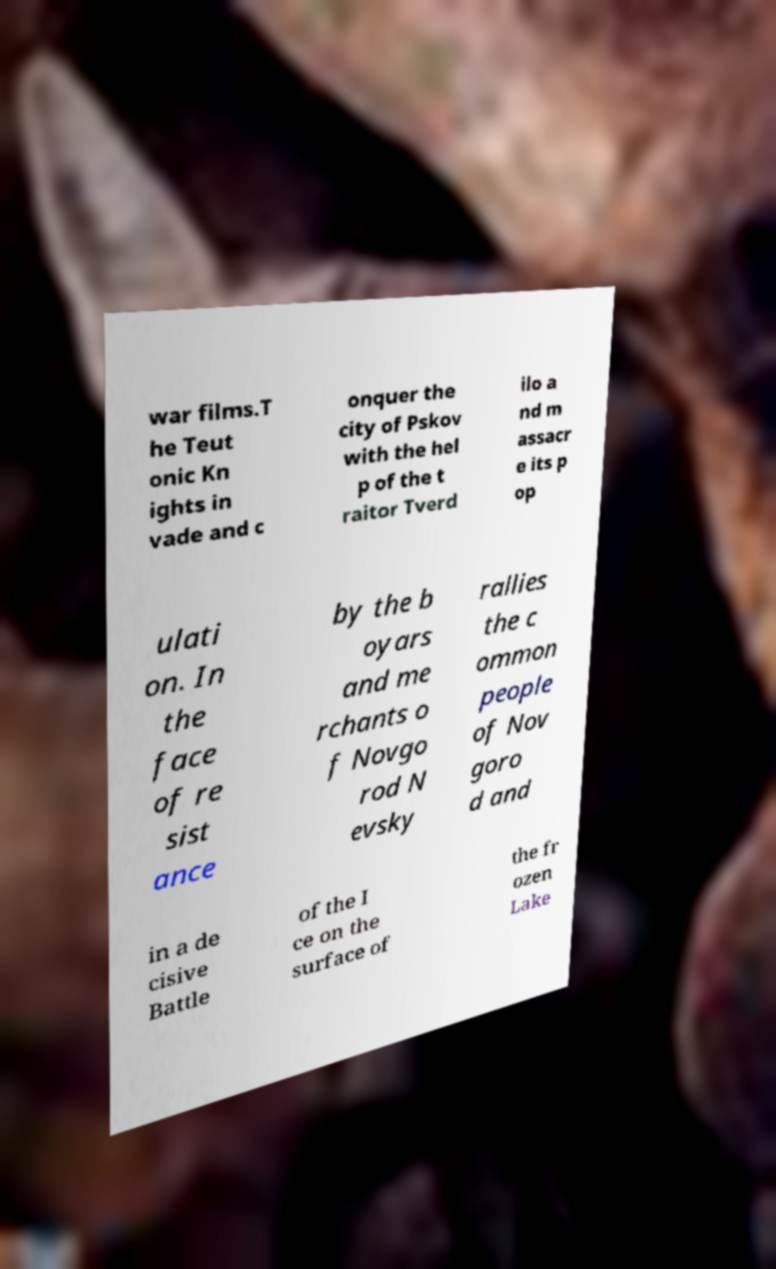I need the written content from this picture converted into text. Can you do that? war films.T he Teut onic Kn ights in vade and c onquer the city of Pskov with the hel p of the t raitor Tverd ilo a nd m assacr e its p op ulati on. In the face of re sist ance by the b oyars and me rchants o f Novgo rod N evsky rallies the c ommon people of Nov goro d and in a de cisive Battle of the I ce on the surface of the fr ozen Lake 